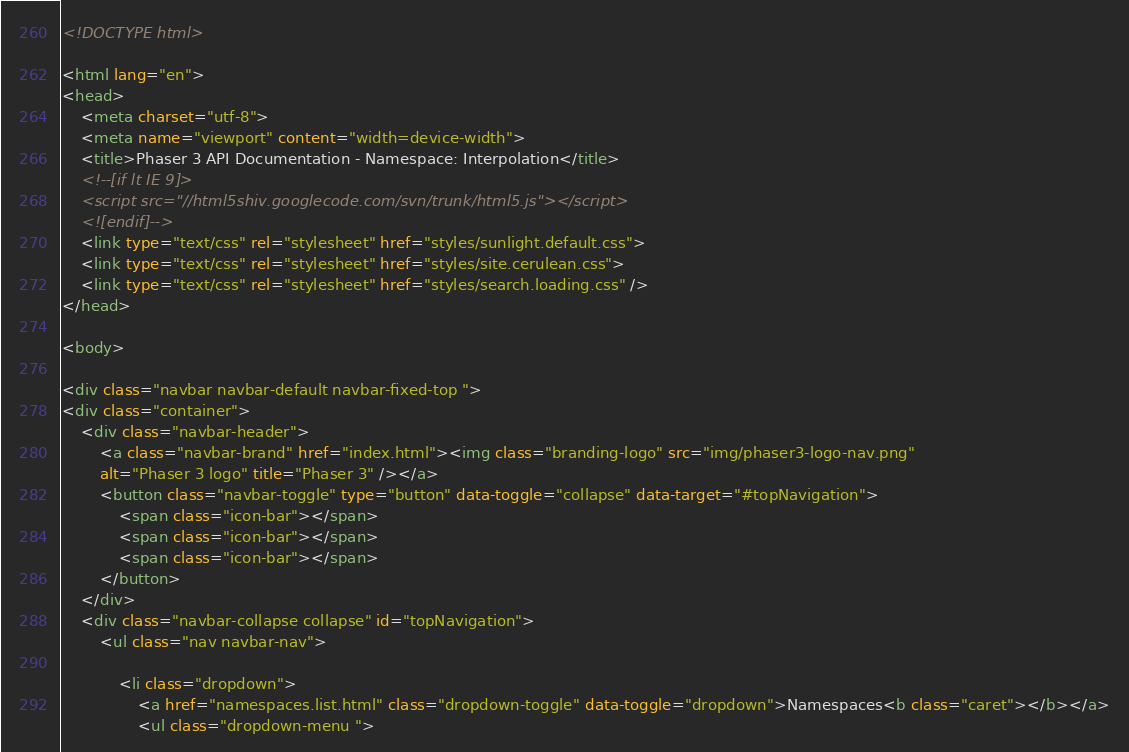Convert code to text. <code><loc_0><loc_0><loc_500><loc_500><_HTML_><!DOCTYPE html>

<html lang="en">
<head>
	<meta charset="utf-8">
	<meta name="viewport" content="width=device-width">
	<title>Phaser 3 API Documentation - Namespace: Interpolation</title>
	<!--[if lt IE 9]>
	<script src="//html5shiv.googlecode.com/svn/trunk/html5.js"></script>
	<![endif]-->
	<link type="text/css" rel="stylesheet" href="styles/sunlight.default.css">
	<link type="text/css" rel="stylesheet" href="styles/site.cerulean.css">
	<link type="text/css" rel="stylesheet" href="styles/search.loading.css" />
</head>

<body>

<div class="navbar navbar-default navbar-fixed-top ">
<div class="container">
	<div class="navbar-header">
		<a class="navbar-brand" href="index.html"><img class="branding-logo" src="img/phaser3-logo-nav.png"
		alt="Phaser 3 logo" title="Phaser 3" /></a>
		<button class="navbar-toggle" type="button" data-toggle="collapse" data-target="#topNavigation">
			<span class="icon-bar"></span>
			<span class="icon-bar"></span>
			<span class="icon-bar"></span>
        </button>
	</div>
	<div class="navbar-collapse collapse" id="topNavigation">
		<ul class="nav navbar-nav">
			
			<li class="dropdown">
				<a href="namespaces.list.html" class="dropdown-toggle" data-toggle="dropdown">Namespaces<b class="caret"></b></a>
				<ul class="dropdown-menu "></code> 